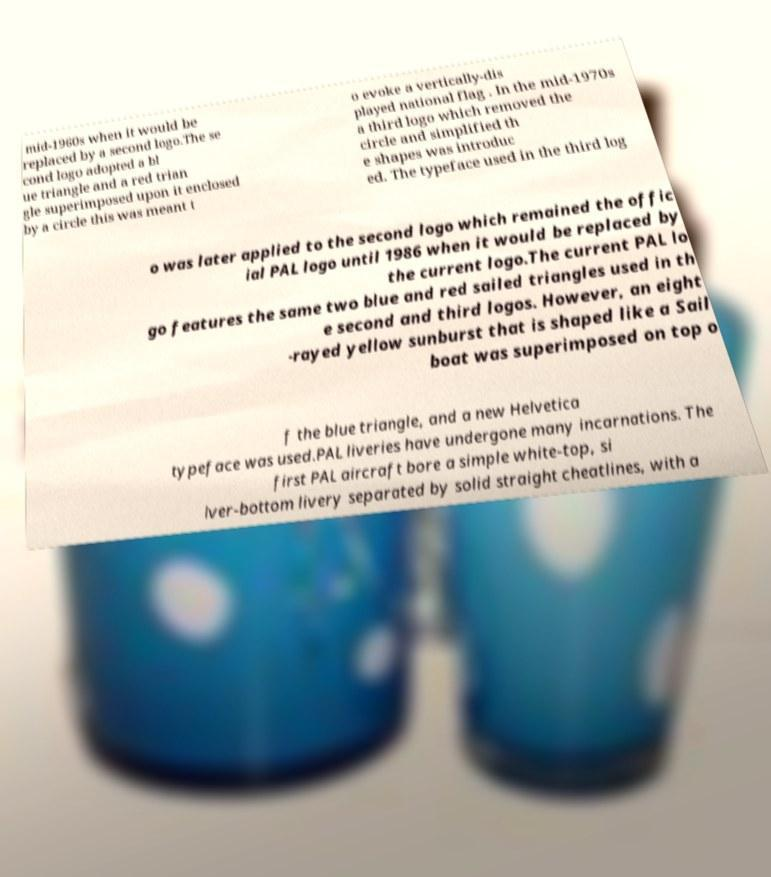Could you assist in decoding the text presented in this image and type it out clearly? mid-1960s when it would be replaced by a second logo.The se cond logo adopted a bl ue triangle and a red trian gle superimposed upon it enclosed by a circle this was meant t o evoke a vertically-dis played national flag . In the mid-1970s a third logo which removed the circle and simplified th e shapes was introduc ed. The typeface used in the third log o was later applied to the second logo which remained the offic ial PAL logo until 1986 when it would be replaced by the current logo.The current PAL lo go features the same two blue and red sailed triangles used in th e second and third logos. However, an eight -rayed yellow sunburst that is shaped like a Sail boat was superimposed on top o f the blue triangle, and a new Helvetica typeface was used.PAL liveries have undergone many incarnations. The first PAL aircraft bore a simple white-top, si lver-bottom livery separated by solid straight cheatlines, with a 